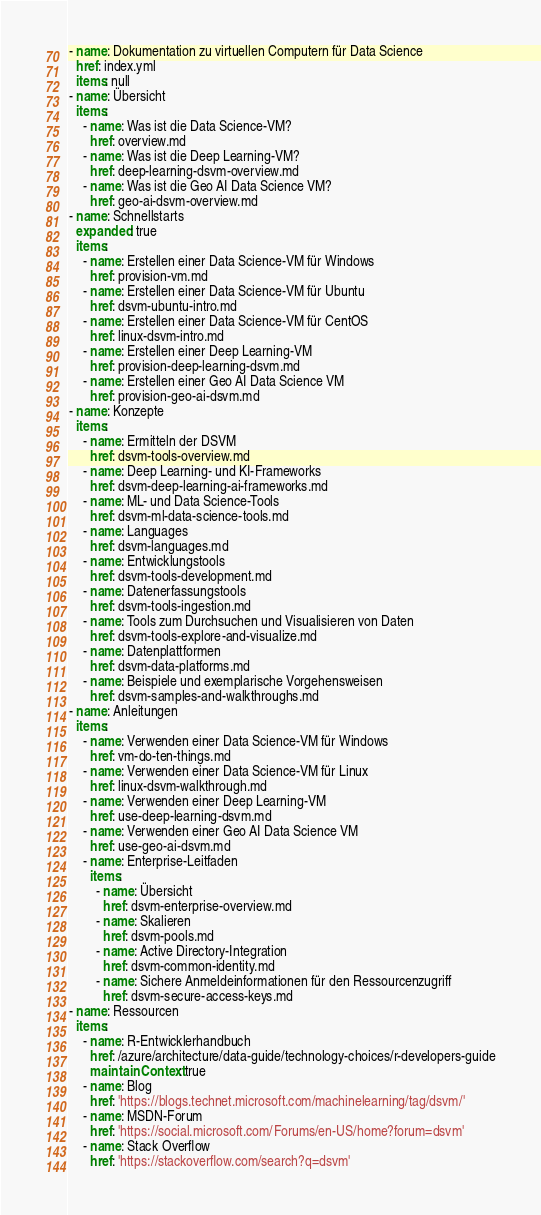Convert code to text. <code><loc_0><loc_0><loc_500><loc_500><_YAML_>- name: Dokumentation zu virtuellen Computern für Data Science
  href: index.yml
  items: null
- name: Übersicht
  items:
    - name: Was ist die Data Science-VM?
      href: overview.md
    - name: Was ist die Deep Learning-VM?
      href: deep-learning-dsvm-overview.md
    - name: Was ist die Geo AI Data Science VM?
      href: geo-ai-dsvm-overview.md
- name: Schnellstarts
  expanded: true
  items:
    - name: Erstellen einer Data Science-VM für Windows
      href: provision-vm.md
    - name: Erstellen einer Data Science-VM für Ubuntu
      href: dsvm-ubuntu-intro.md
    - name: Erstellen einer Data Science-VM für CentOS
      href: linux-dsvm-intro.md
    - name: Erstellen einer Deep Learning-VM
      href: provision-deep-learning-dsvm.md
    - name: Erstellen einer Geo AI Data Science VM
      href: provision-geo-ai-dsvm.md
- name: Konzepte
  items:
    - name: Ermitteln der DSVM
      href: dsvm-tools-overview.md
    - name: Deep Learning- und KI-Frameworks
      href: dsvm-deep-learning-ai-frameworks.md
    - name: ML- und Data Science-Tools
      href: dsvm-ml-data-science-tools.md
    - name: Languages
      href: dsvm-languages.md
    - name: Entwicklungstools
      href: dsvm-tools-development.md
    - name: Datenerfassungstools
      href: dsvm-tools-ingestion.md
    - name: Tools zum Durchsuchen und Visualisieren von Daten
      href: dsvm-tools-explore-and-visualize.md
    - name: Datenplattformen
      href: dsvm-data-platforms.md
    - name: Beispiele und exemplarische Vorgehensweisen
      href: dsvm-samples-and-walkthroughs.md
- name: Anleitungen
  items:
    - name: Verwenden einer Data Science-VM für Windows
      href: vm-do-ten-things.md
    - name: Verwenden einer Data Science-VM für Linux
      href: linux-dsvm-walkthrough.md
    - name: Verwenden einer Deep Learning-VM
      href: use-deep-learning-dsvm.md
    - name: Verwenden einer Geo AI Data Science VM
      href: use-geo-ai-dsvm.md
    - name: Enterprise-Leitfaden
      items:
        - name: Übersicht
          href: dsvm-enterprise-overview.md
        - name: Skalieren
          href: dsvm-pools.md
        - name: Active Directory-Integration
          href: dsvm-common-identity.md
        - name: Sichere Anmeldeinformationen für den Ressourcenzugriff
          href: dsvm-secure-access-keys.md
- name: Ressourcen
  items:
    - name: R-Entwicklerhandbuch
      href: /azure/architecture/data-guide/technology-choices/r-developers-guide
      maintainContext: true
    - name: Blog
      href: 'https://blogs.technet.microsoft.com/machinelearning/tag/dsvm/'
    - name: MSDN-Forum
      href: 'https://social.microsoft.com/Forums/en-US/home?forum=dsvm'
    - name: Stack Overflow
      href: 'https://stackoverflow.com/search?q=dsvm'</code> 